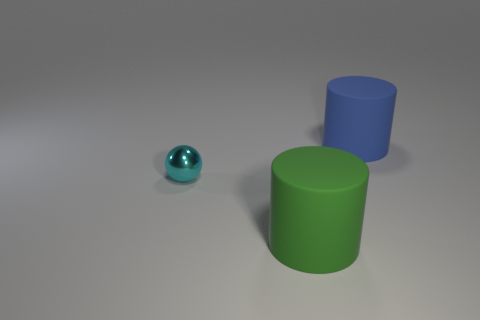Is there anything else that has the same material as the small cyan thing?
Make the answer very short. No. Are there any other things that have the same size as the cyan shiny ball?
Your response must be concise. No. Are there fewer big matte cylinders that are in front of the shiny object than small shiny things behind the blue rubber thing?
Provide a succinct answer. No. Is the color of the big matte thing behind the metal object the same as the rubber cylinder in front of the blue cylinder?
Give a very brief answer. No. There is a thing that is in front of the big blue cylinder and to the right of the cyan thing; what is its material?
Your answer should be compact. Rubber. Are there any small metal balls?
Your answer should be compact. Yes. What shape is the green object that is the same material as the blue object?
Keep it short and to the point. Cylinder. Do the blue object and the large thing in front of the small cyan metallic object have the same shape?
Provide a short and direct response. Yes. The cylinder that is in front of the big thing that is behind the green cylinder is made of what material?
Your response must be concise. Rubber. What number of other objects are there of the same shape as the big blue thing?
Provide a short and direct response. 1. 